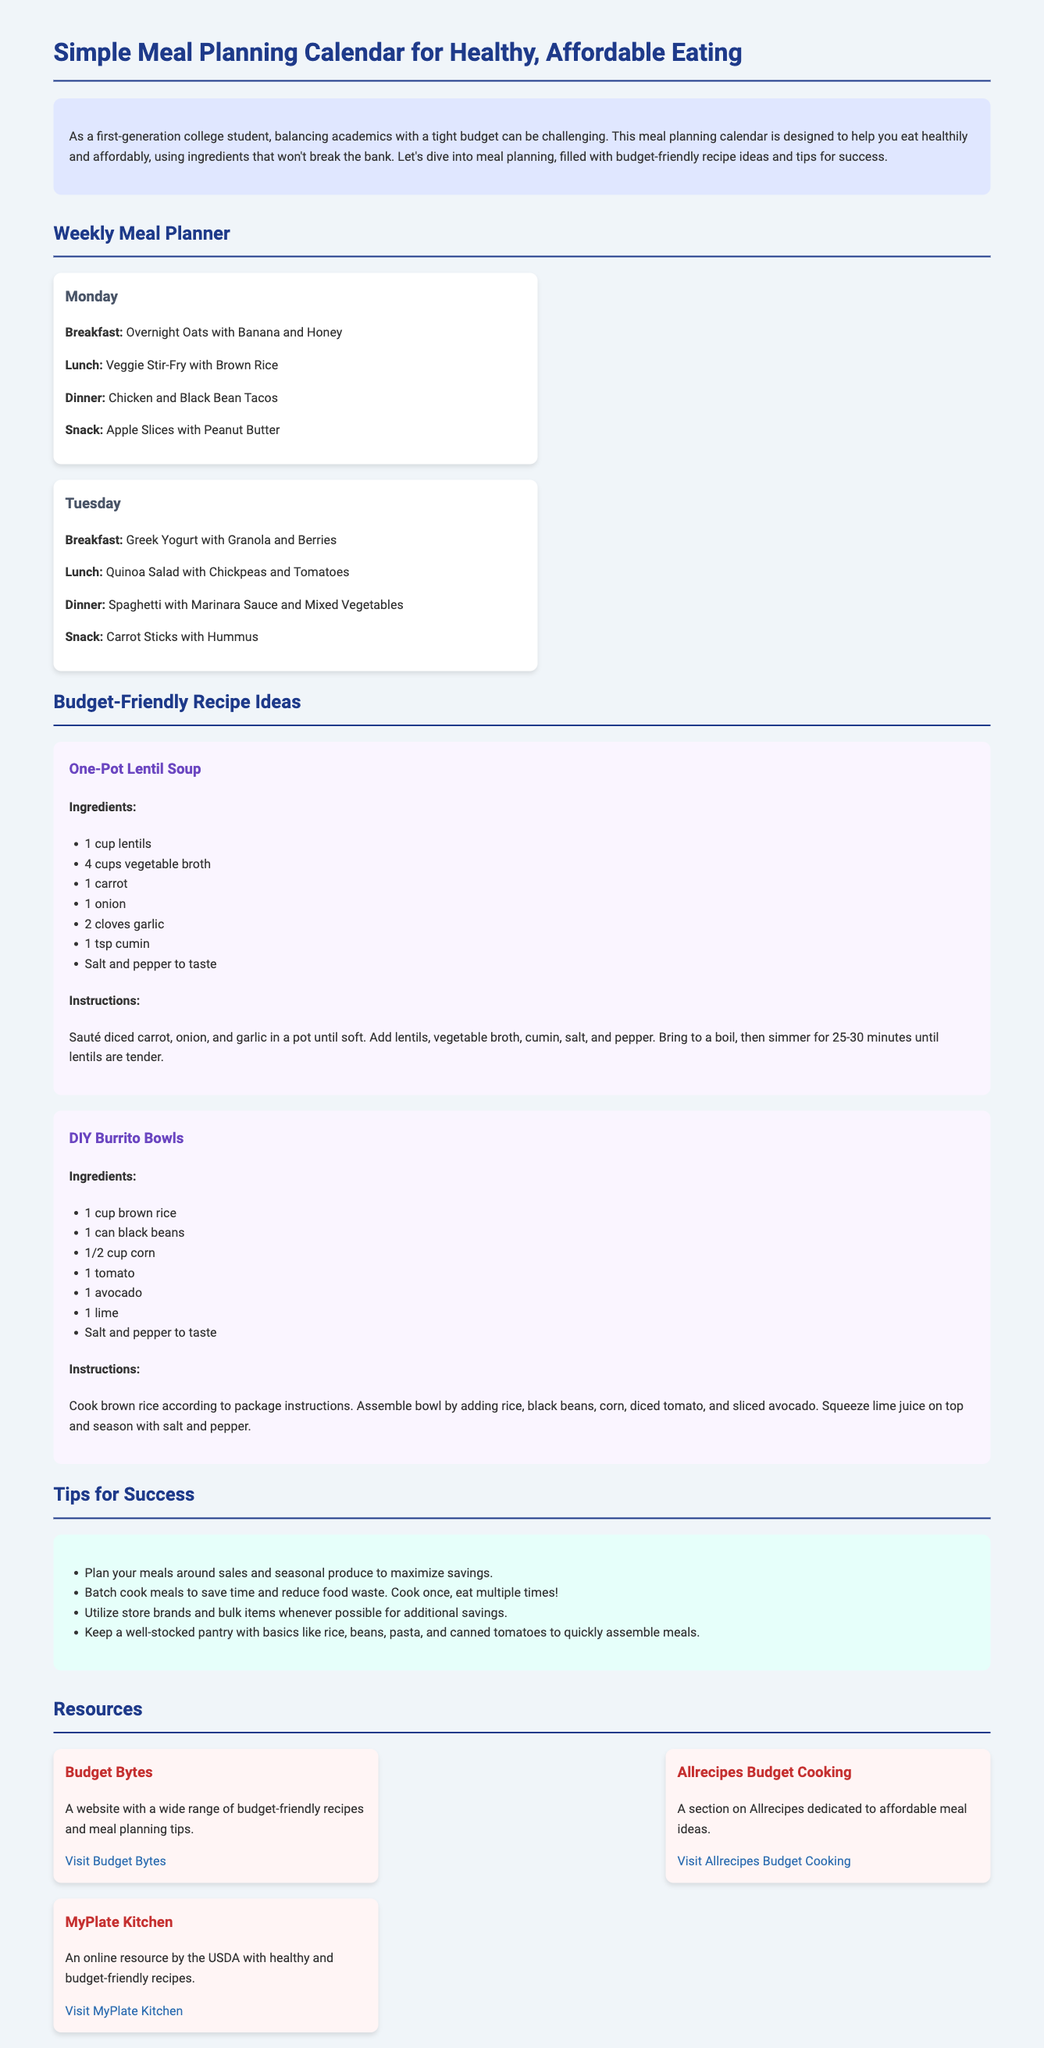What is the title of the document? The title is mentioned in the heading at the top of the document.
Answer: Simple Meal Planning Calendar for Healthy, Affordable Eating What is the purpose of the meal planning calendar? The purpose is described in the introductory paragraph and aims to assist first-generation college students.
Answer: Help you eat healthily and affordably How many days are included in the weekly meal planner? The weekly meal planner details meals for each day and is typically seven days long.
Answer: Seven days What is one ingredient in the One-Pot Lentil Soup recipe? The ingredient list provided in the recipe specifies several items.
Answer: Lentils What meal is suggested for lunch on Tuesday? The meal planner outlines specific meals for each day, including lunches.
Answer: Quinoa Salad with Chickpeas and Tomatoes What is one tip for saving money according to the tips section? The tips section provides various strategies for budget-friendly meal planning.
Answer: Plan your meals around sales How many resources are listed in the resources section? The resources section presents a list of various budget-friendly cooking websites.
Answer: Three resources What is the primary audience mentioned for this meal planning calendar? The introductory paragraph specifies the intended users of the calendar.
Answer: First-generation college students What snack is suggested for Monday? The meal planner specifies snacks for each day, including Monday.
Answer: Apple Slices with Peanut Butter 